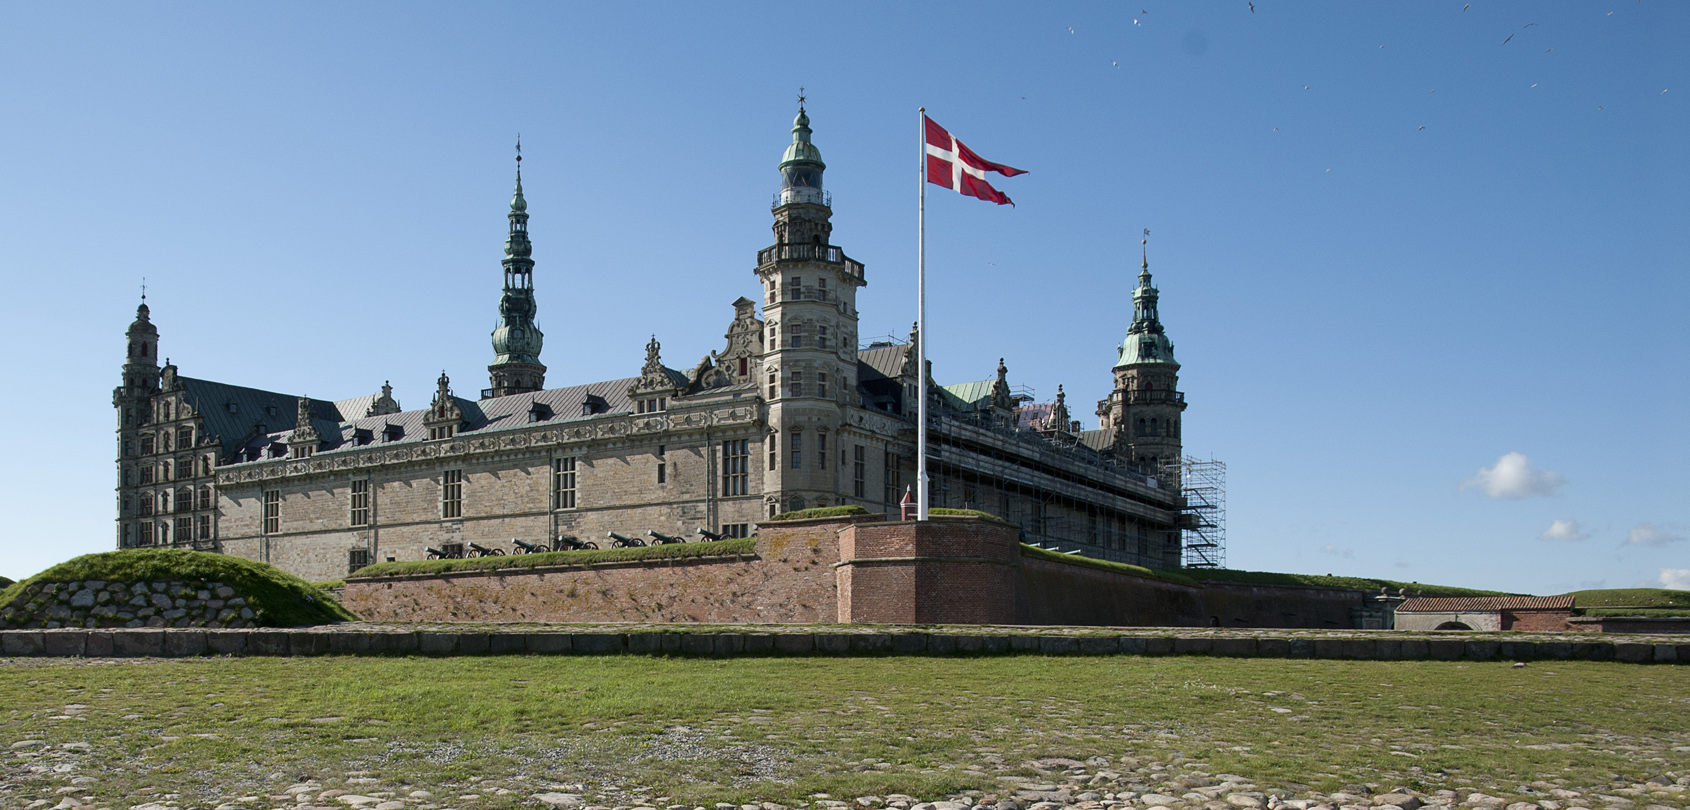Can you tell me more about the architecture and artistic features of Kronborg Castle? Certainly! Kronborg Castle is a fine example of Renaissance architecture, characterized by its symmetrical layout and elaborate sandstone decorations. The castle's interior is equally impressive with intricately designed chambers, the grand ballroom and the chapel, all adorned with Renaissance artworks, tapestries, and ornate furnishings. The spires and towers, particularly the central tower, are topped with copper roofs that have oxidized to a distinctive green hue, adding to the visual appeal of this historic edifice. 